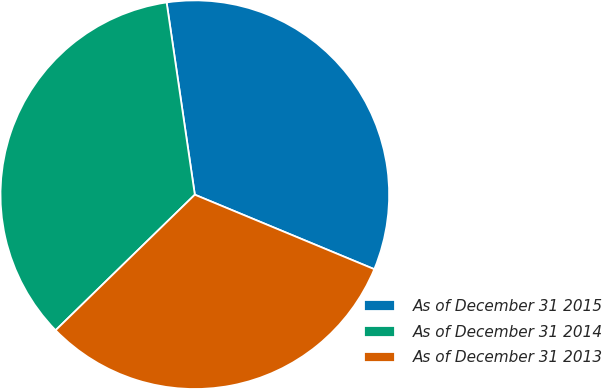Convert chart. <chart><loc_0><loc_0><loc_500><loc_500><pie_chart><fcel>As of December 31 2015<fcel>As of December 31 2014<fcel>As of December 31 2013<nl><fcel>33.58%<fcel>34.97%<fcel>31.45%<nl></chart> 